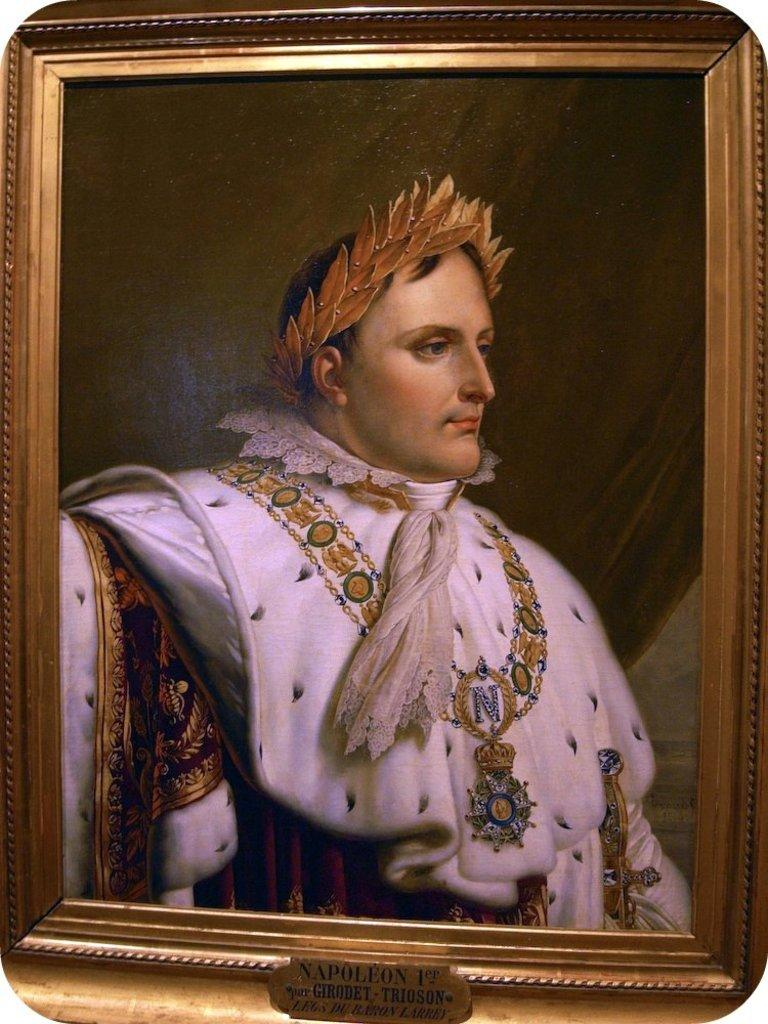What object is present in the image that typically holds a photograph? There is a photo frame in the image. Who is featured in the photo within the frame? There is a man in the photo frame. Is there any additional information provided with the photo frame? Yes, there is a name plate with text on it fixed to the photo frame. How many books are stacked on the vase in the image? There is no vase or books present in the image. What type of bird can be seen perched on the name plate in the image? There is no bird present in the image. 